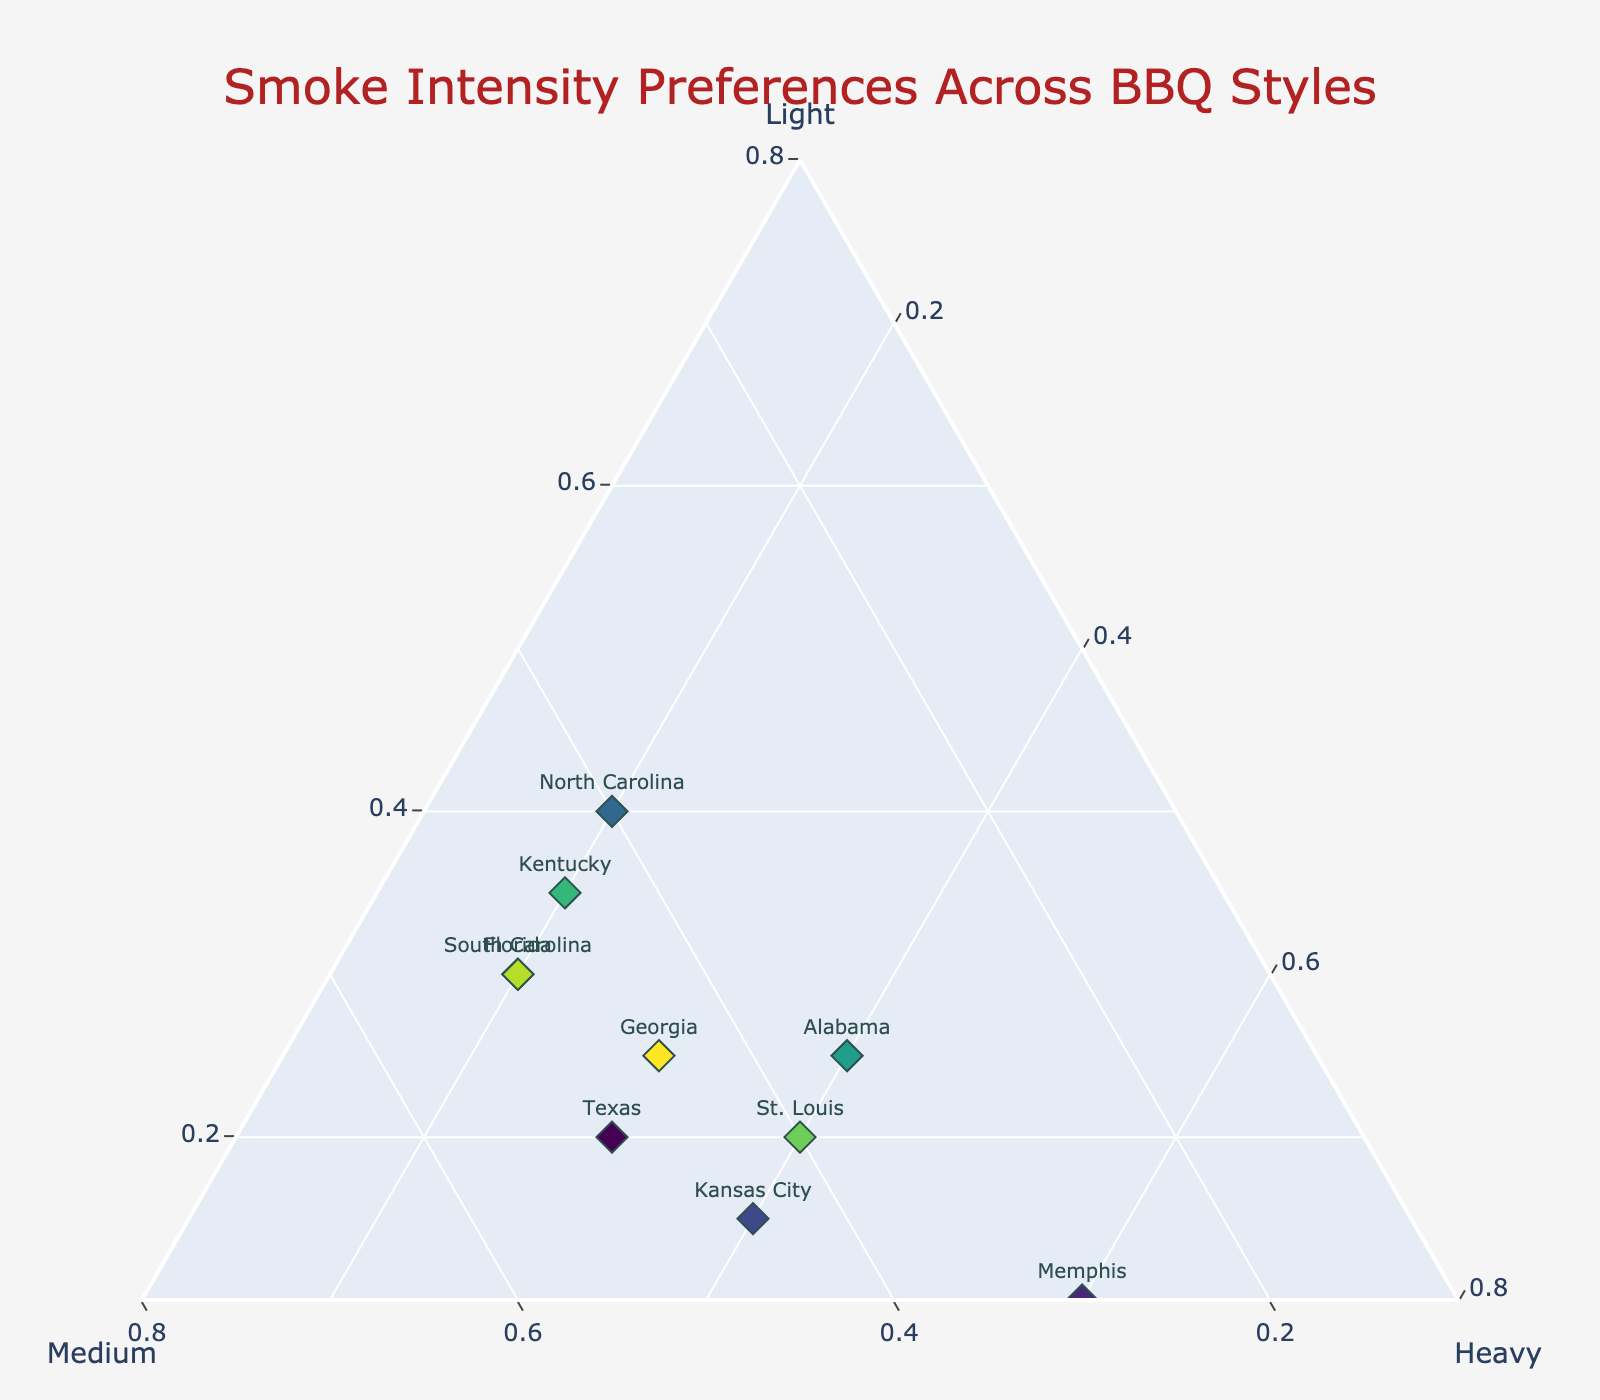How many regions are plotted in the Ternary Plot? By counting the labels corresponding to the regions on the plot, we can see that there are 10 different regions indicated.
Answer: 10 Which region has the highest preference for heavy smoke intensity? The region with the highest 'Heavy' value among the plotted points has 0.6 for Heavy, which is Memphis.
Answer: Memphis Which region prefers medium smoke intensity the least? The region with the minimum 'Medium' value looks closer to the base of the Medium axis. North Carolina has the lowest Medium preference at 0.4.
Answer: North Carolina Compare the smoke preference between Alabama and Georgia. Which region has a higher preference for light smoke? Checking the plot markers for both Alabama and Georgia, Alabama has a 0.25 preference for Light, while Georgia also has 0.25. Therefore, both have the same preference for light smoke.
Answer: Both are equal What is the general trend for smoke preferences in Texas? By looking at the plot point labeled Texas, it shows Light: 0.2, Medium: 0.5, and Heavy: 0.3, indicating a higher preference for Medium smoke.
Answer: Higher preference for Medium Which two regions have identical preferences for light smoke intensity? Observing the markers, both St. Louis and Texas have a Light preference of 0.2.
Answer: St. Louis and Texas How does the smoke preference in South Carolina differ from Florida in terms of Heavy intensity? The plot shows South Carolina with 0.2 for Heavy while Florida also has 0.2 for Heavy. Therefore, there is no difference in Heavy intensity preference between these two regions.
Answer: No difference Determine the regions that have an equal preference for Medium smoke intensity. From the plot, we see that Texas, South Carolina, and Florida each have a Medium preference of 0.5.
Answer: Texas, South Carolina, Florida Which region falls closest to the median preference for Medium smoke? To find this, order regions by their Medium intensity: Memphis (0.3), Alabama (0.35), North Carolina (0.4), St. Louis (0.4), Kansas City (0.45), Georgia (0.45), Kentucky (0.45), and Texas, South Carolina, Florida (0.5). The median value seems to be around the 5th position, corresponding to Kansas City, Georgia, and Kentucky (0.45).
Answer: Kansas City, Georgia, Kentucky 